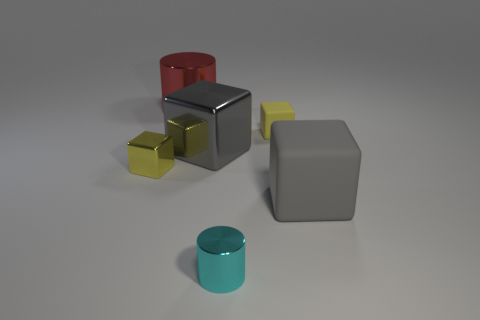Subtract 1 blocks. How many blocks are left? 3 Subtract all cyan cubes. Subtract all red cylinders. How many cubes are left? 4 Add 4 gray objects. How many objects exist? 10 Subtract all cubes. How many objects are left? 2 Subtract all green metal cubes. Subtract all large gray shiny objects. How many objects are left? 5 Add 1 small objects. How many small objects are left? 4 Add 4 big gray balls. How many big gray balls exist? 4 Subtract 0 purple cylinders. How many objects are left? 6 